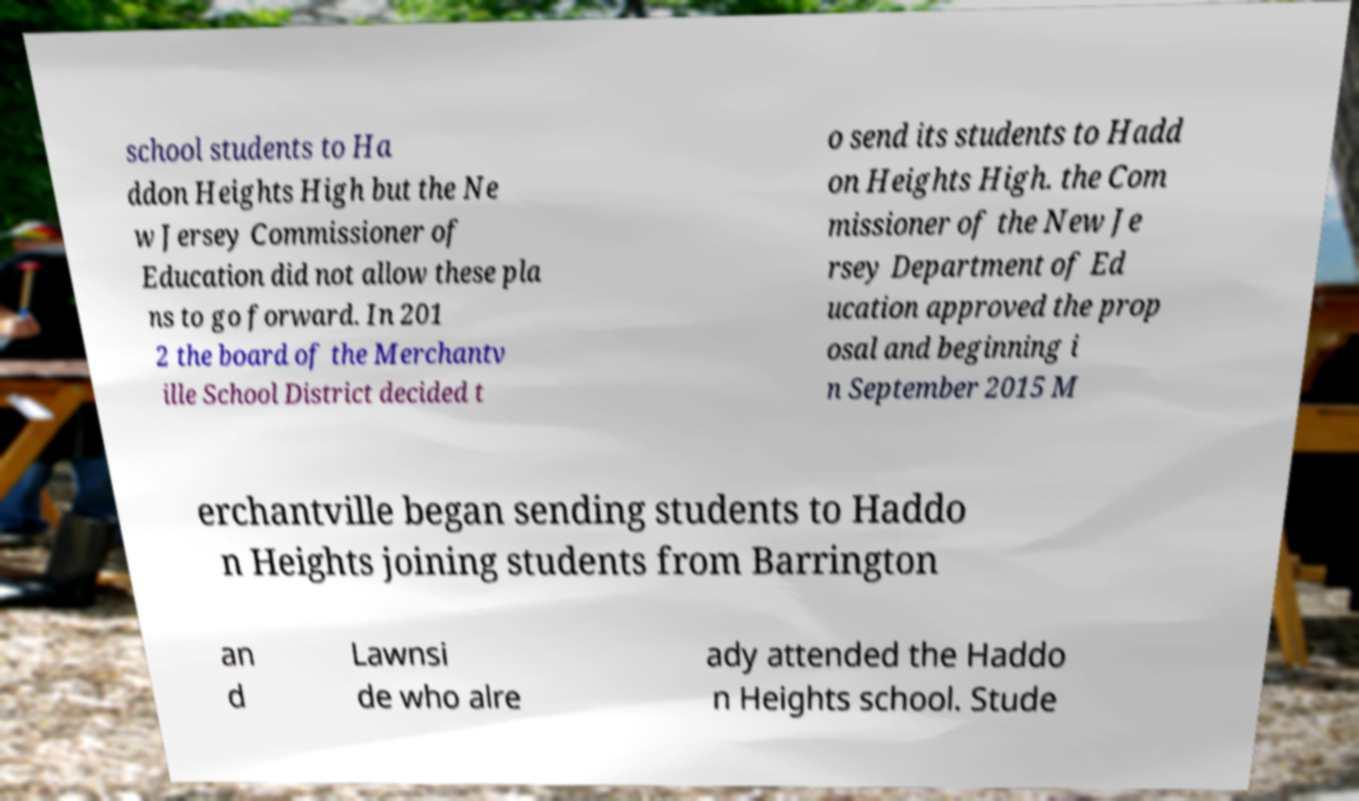I need the written content from this picture converted into text. Can you do that? school students to Ha ddon Heights High but the Ne w Jersey Commissioner of Education did not allow these pla ns to go forward. In 201 2 the board of the Merchantv ille School District decided t o send its students to Hadd on Heights High. the Com missioner of the New Je rsey Department of Ed ucation approved the prop osal and beginning i n September 2015 M erchantville began sending students to Haddo n Heights joining students from Barrington an d Lawnsi de who alre ady attended the Haddo n Heights school. Stude 